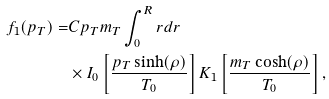<formula> <loc_0><loc_0><loc_500><loc_500>f _ { 1 } ( p _ { T } ) = & C p _ { T } m _ { T } \int _ { 0 } ^ { R } r d r \\ & \times I _ { 0 } \left [ \frac { p _ { T } \sinh ( \rho ) } { T _ { 0 } } \right ] K _ { 1 } \left [ \frac { m _ { T } \cosh ( \rho ) } { T _ { 0 } } \right ] ,</formula> 